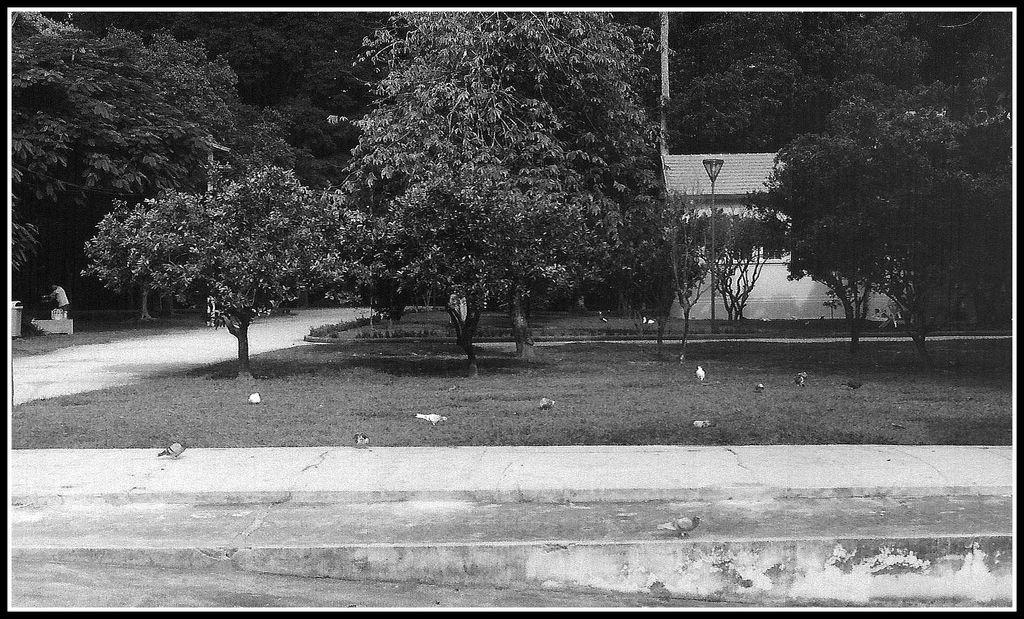What type of location is shown in the image? The image depicts a garden. What can be found in abundance within the garden? There are many trees in the garden. What structure is visible behind the trees? There is a house behind the trees. What is located behind the house in the image? There is a thicket behind the house. What type of air is being represented in the image? The image does not depict any specific type of air; it shows a garden with trees, a house, and a thicket. Is there any wool visible in the image? There is no wool present in the image. 